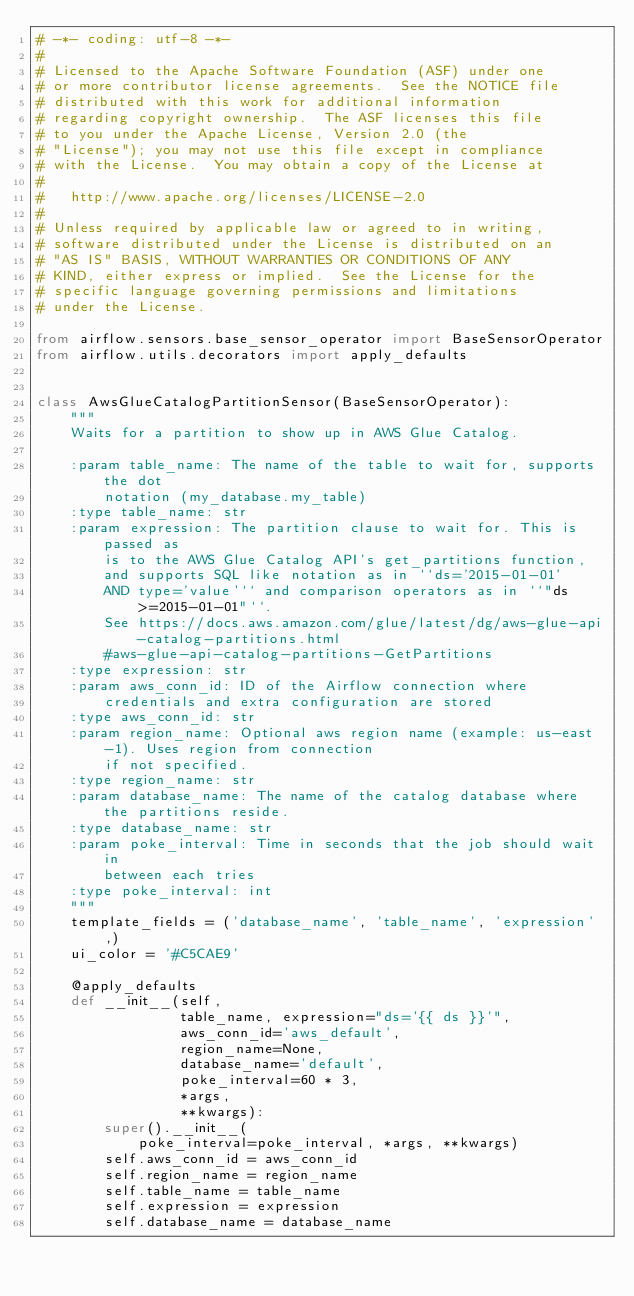<code> <loc_0><loc_0><loc_500><loc_500><_Python_># -*- coding: utf-8 -*-
#
# Licensed to the Apache Software Foundation (ASF) under one
# or more contributor license agreements.  See the NOTICE file
# distributed with this work for additional information
# regarding copyright ownership.  The ASF licenses this file
# to you under the Apache License, Version 2.0 (the
# "License"); you may not use this file except in compliance
# with the License.  You may obtain a copy of the License at
#
#   http://www.apache.org/licenses/LICENSE-2.0
#
# Unless required by applicable law or agreed to in writing,
# software distributed under the License is distributed on an
# "AS IS" BASIS, WITHOUT WARRANTIES OR CONDITIONS OF ANY
# KIND, either express or implied.  See the License for the
# specific language governing permissions and limitations
# under the License.

from airflow.sensors.base_sensor_operator import BaseSensorOperator
from airflow.utils.decorators import apply_defaults


class AwsGlueCatalogPartitionSensor(BaseSensorOperator):
    """
    Waits for a partition to show up in AWS Glue Catalog.

    :param table_name: The name of the table to wait for, supports the dot
        notation (my_database.my_table)
    :type table_name: str
    :param expression: The partition clause to wait for. This is passed as
        is to the AWS Glue Catalog API's get_partitions function,
        and supports SQL like notation as in ``ds='2015-01-01'
        AND type='value'`` and comparison operators as in ``"ds>=2015-01-01"``.
        See https://docs.aws.amazon.com/glue/latest/dg/aws-glue-api-catalog-partitions.html
        #aws-glue-api-catalog-partitions-GetPartitions
    :type expression: str
    :param aws_conn_id: ID of the Airflow connection where
        credentials and extra configuration are stored
    :type aws_conn_id: str
    :param region_name: Optional aws region name (example: us-east-1). Uses region from connection
        if not specified.
    :type region_name: str
    :param database_name: The name of the catalog database where the partitions reside.
    :type database_name: str
    :param poke_interval: Time in seconds that the job should wait in
        between each tries
    :type poke_interval: int
    """
    template_fields = ('database_name', 'table_name', 'expression',)
    ui_color = '#C5CAE9'

    @apply_defaults
    def __init__(self,
                 table_name, expression="ds='{{ ds }}'",
                 aws_conn_id='aws_default',
                 region_name=None,
                 database_name='default',
                 poke_interval=60 * 3,
                 *args,
                 **kwargs):
        super().__init__(
            poke_interval=poke_interval, *args, **kwargs)
        self.aws_conn_id = aws_conn_id
        self.region_name = region_name
        self.table_name = table_name
        self.expression = expression
        self.database_name = database_name
</code> 